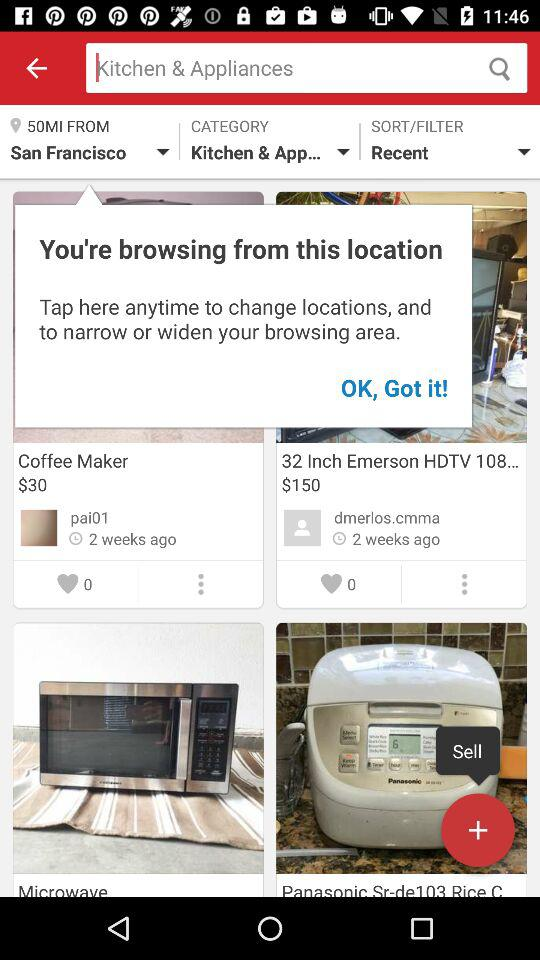What is the price for the 32-inch Emerson HDTV108? The price for the 32-inch Emerson HDTV108 is $150. 